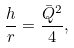<formula> <loc_0><loc_0><loc_500><loc_500>\frac { h } { r } = \frac { \bar { Q } ^ { 2 } } { 4 } ,</formula> 